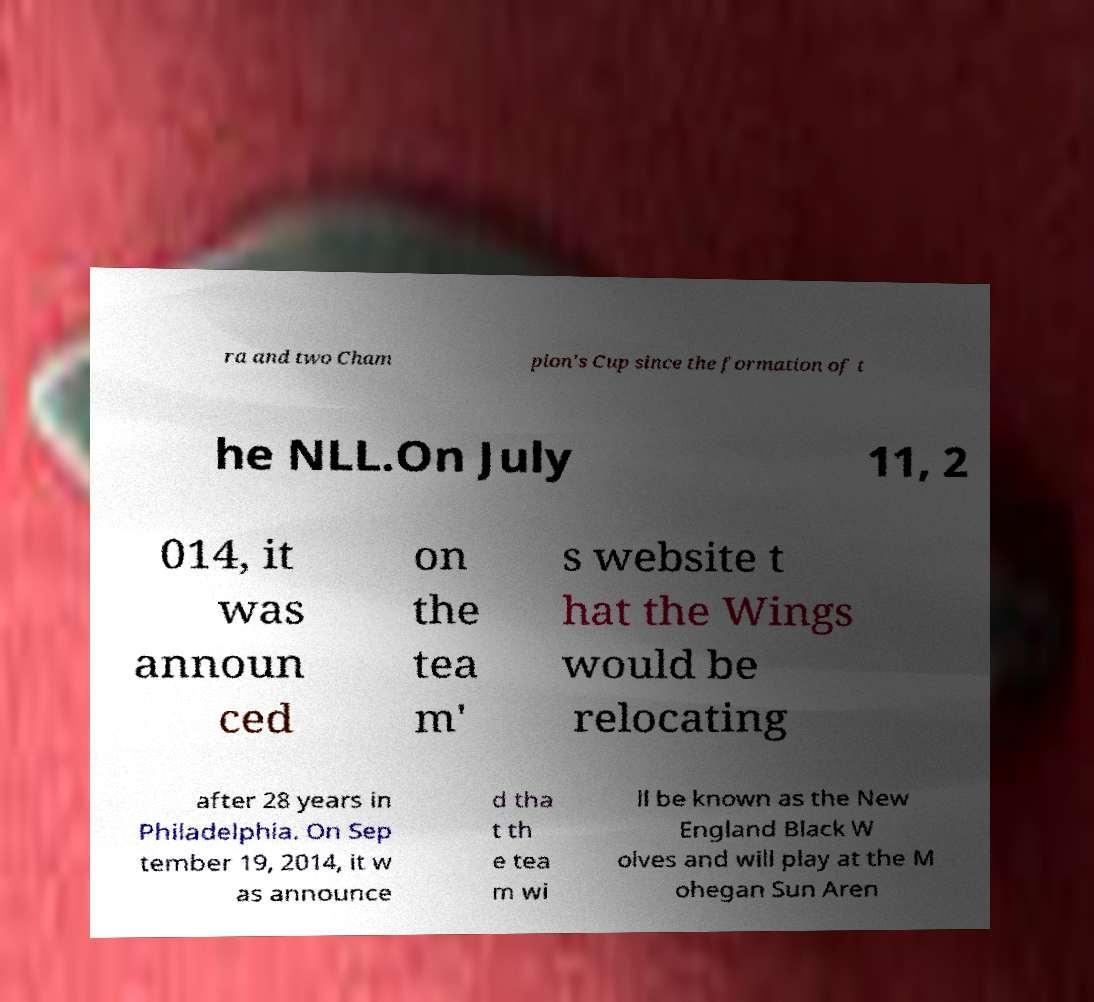For documentation purposes, I need the text within this image transcribed. Could you provide that? ra and two Cham pion's Cup since the formation of t he NLL.On July 11, 2 014, it was announ ced on the tea m' s website t hat the Wings would be relocating after 28 years in Philadelphia. On Sep tember 19, 2014, it w as announce d tha t th e tea m wi ll be known as the New England Black W olves and will play at the M ohegan Sun Aren 